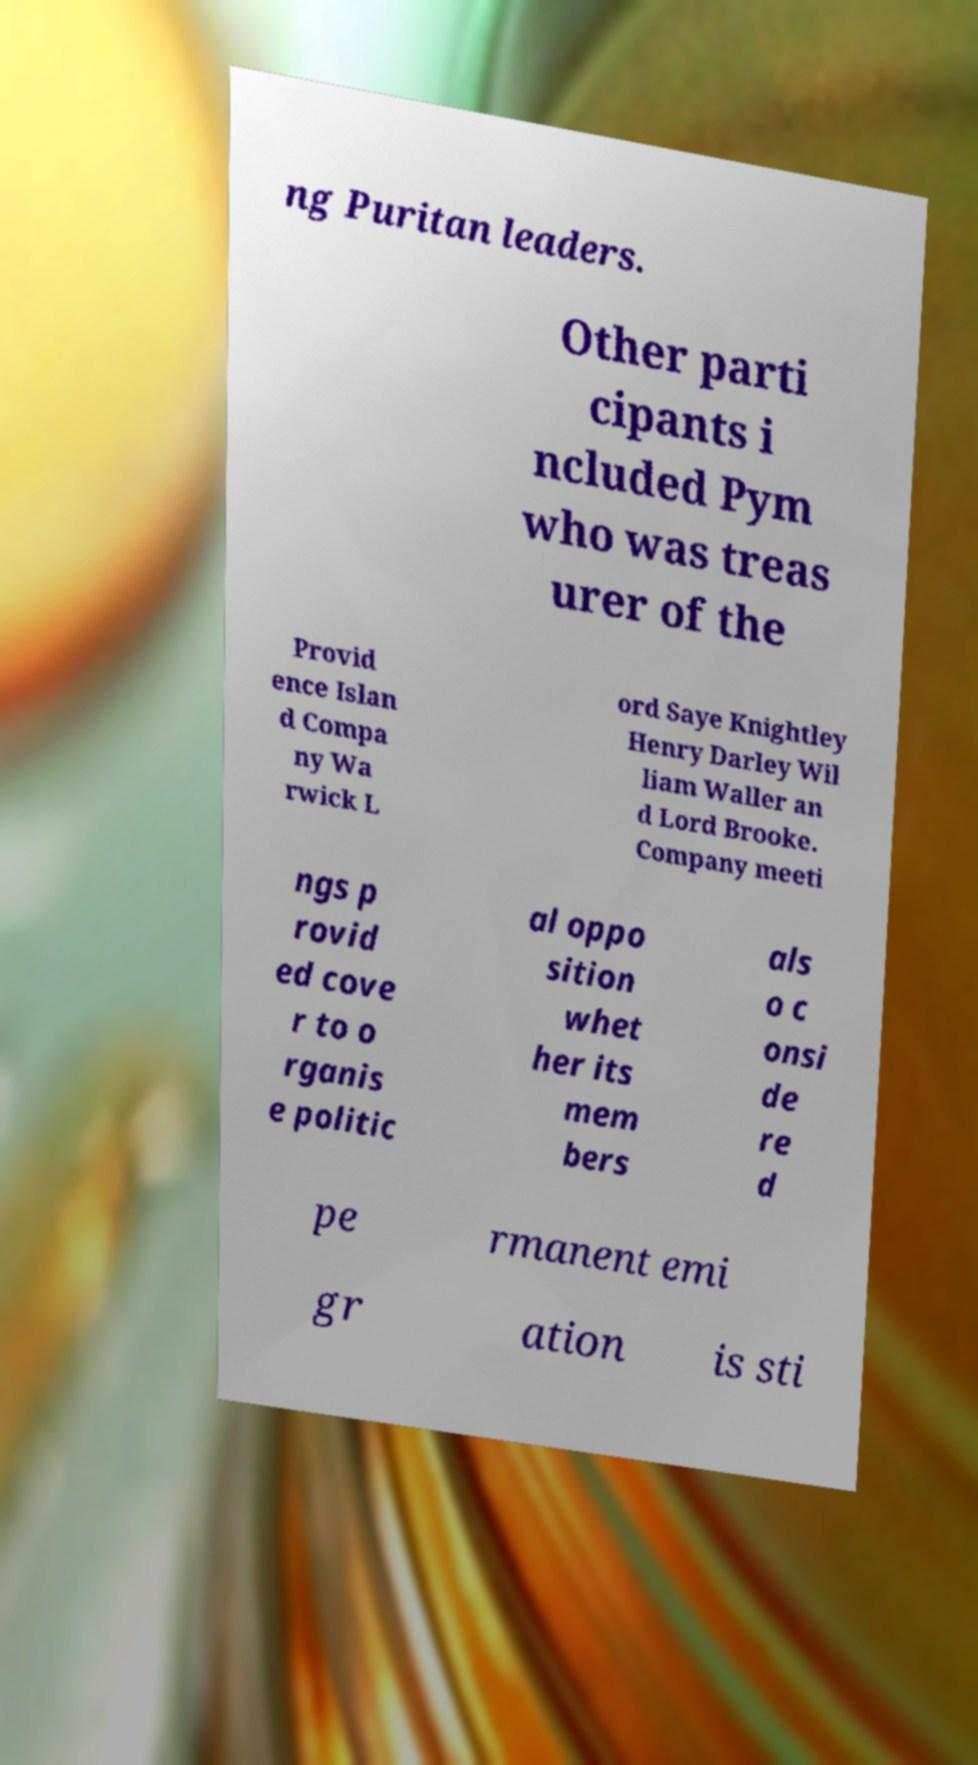Can you accurately transcribe the text from the provided image for me? ng Puritan leaders. Other parti cipants i ncluded Pym who was treas urer of the Provid ence Islan d Compa ny Wa rwick L ord Saye Knightley Henry Darley Wil liam Waller an d Lord Brooke. Company meeti ngs p rovid ed cove r to o rganis e politic al oppo sition whet her its mem bers als o c onsi de re d pe rmanent emi gr ation is sti 